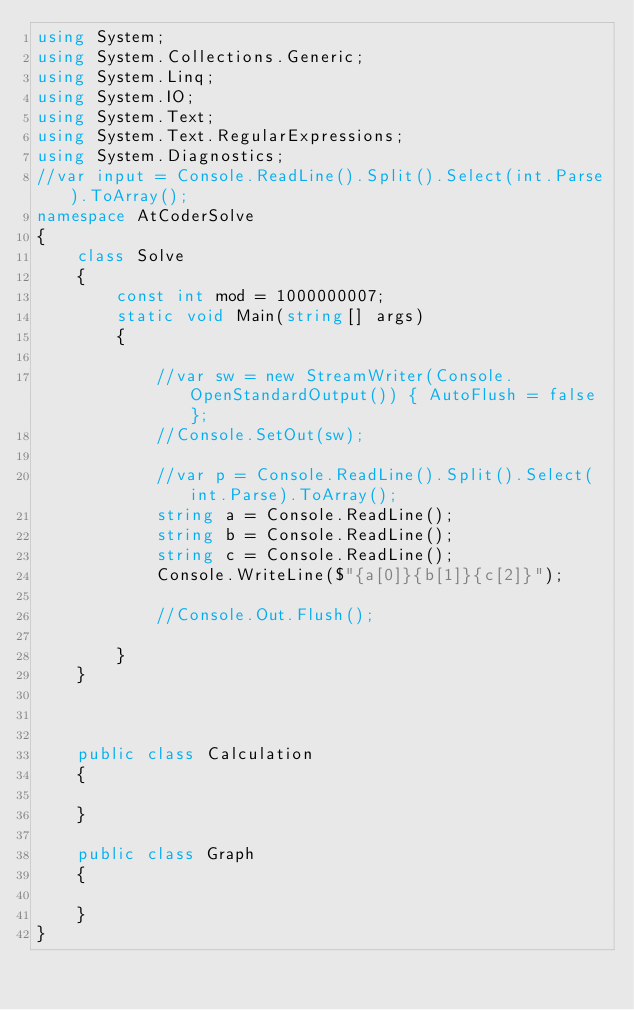<code> <loc_0><loc_0><loc_500><loc_500><_C#_>using System;
using System.Collections.Generic;
using System.Linq;
using System.IO;
using System.Text;
using System.Text.RegularExpressions;
using System.Diagnostics;
//var input = Console.ReadLine().Split().Select(int.Parse).ToArray();
namespace AtCoderSolve
{
    class Solve
    {
        const int mod = 1000000007;
        static void Main(string[] args)
        {

            //var sw = new StreamWriter(Console.OpenStandardOutput()) { AutoFlush = false };
            //Console.SetOut(sw);

            //var p = Console.ReadLine().Split().Select(int.Parse).ToArray();
            string a = Console.ReadLine();
            string b = Console.ReadLine();
            string c = Console.ReadLine();
            Console.WriteLine($"{a[0]}{b[1]}{c[2]}");

            //Console.Out.Flush();

        }
    }



    public class Calculation
    {

    }

    public class Graph
    {

    }
}
</code> 